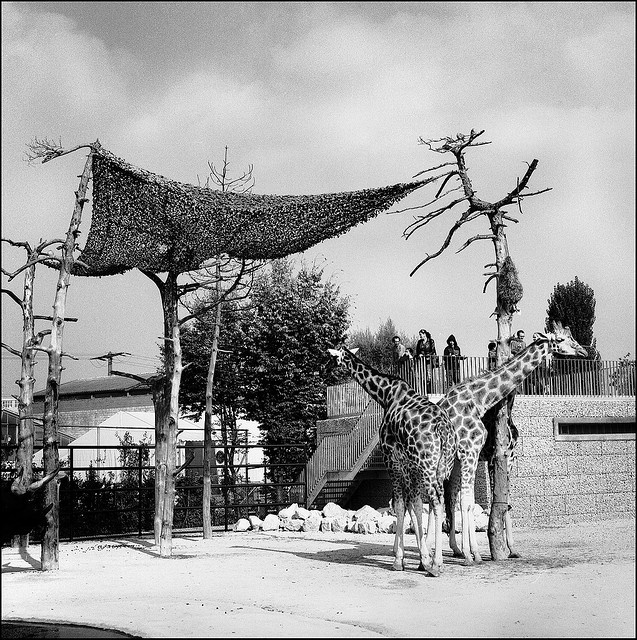Describe the objects in this image and their specific colors. I can see giraffe in black, gray, darkgray, and lightgray tones, giraffe in black, lightgray, darkgray, and gray tones, people in black, gray, lightgray, and darkgray tones, people in black, gray, darkgray, and lightgray tones, and people in black, gray, darkgray, and gainsboro tones in this image. 